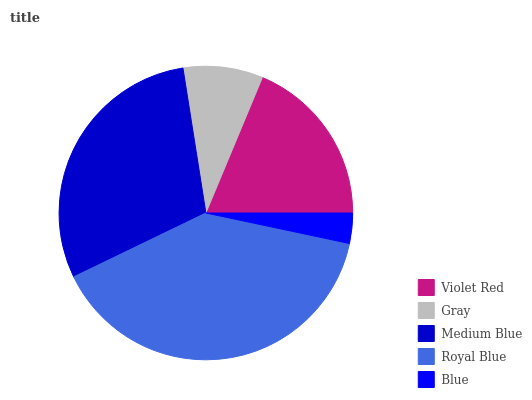Is Blue the minimum?
Answer yes or no. Yes. Is Royal Blue the maximum?
Answer yes or no. Yes. Is Gray the minimum?
Answer yes or no. No. Is Gray the maximum?
Answer yes or no. No. Is Violet Red greater than Gray?
Answer yes or no. Yes. Is Gray less than Violet Red?
Answer yes or no. Yes. Is Gray greater than Violet Red?
Answer yes or no. No. Is Violet Red less than Gray?
Answer yes or no. No. Is Violet Red the high median?
Answer yes or no. Yes. Is Violet Red the low median?
Answer yes or no. Yes. Is Royal Blue the high median?
Answer yes or no. No. Is Medium Blue the low median?
Answer yes or no. No. 